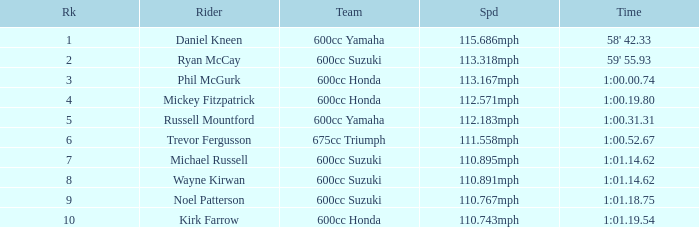How many ranks have michael russell as the rider? 7.0. 